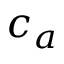<formula> <loc_0><loc_0><loc_500><loc_500>c _ { a }</formula> 